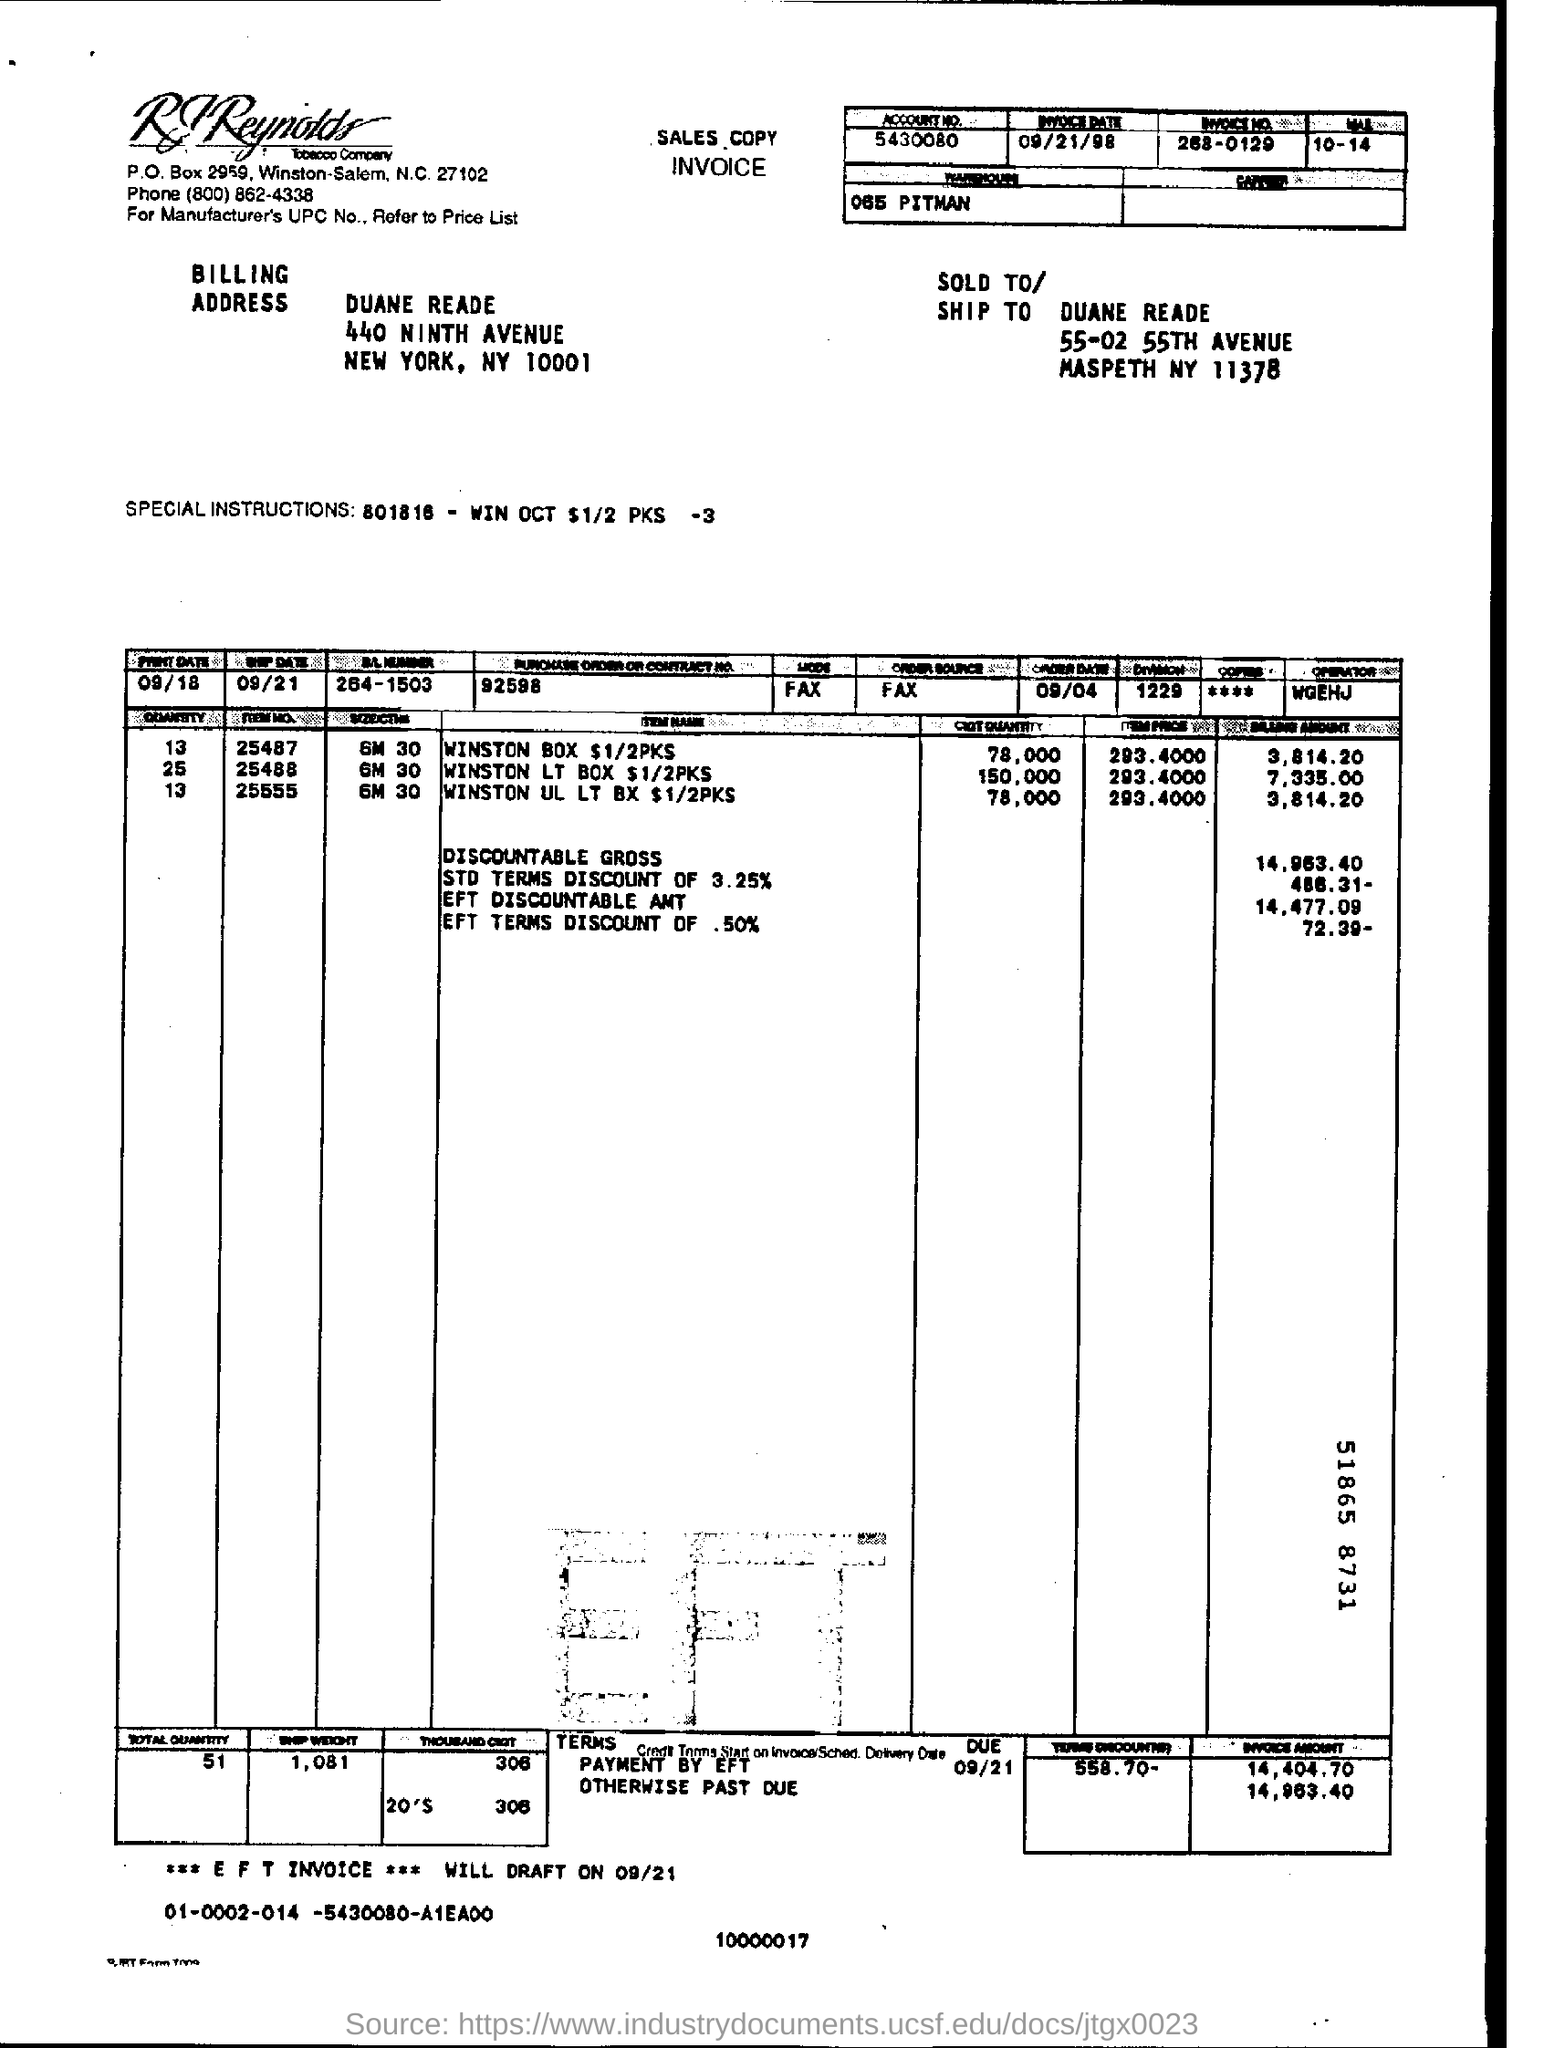Outline some significant characteristics in this image. The date mentioned in this document is 09/21/98. The account number listed on the invoice is 5430080... The invoice number provided in the document is 268-0129. Please provide the Purchase Order or contract number listed on the invoice, which is 92598. 